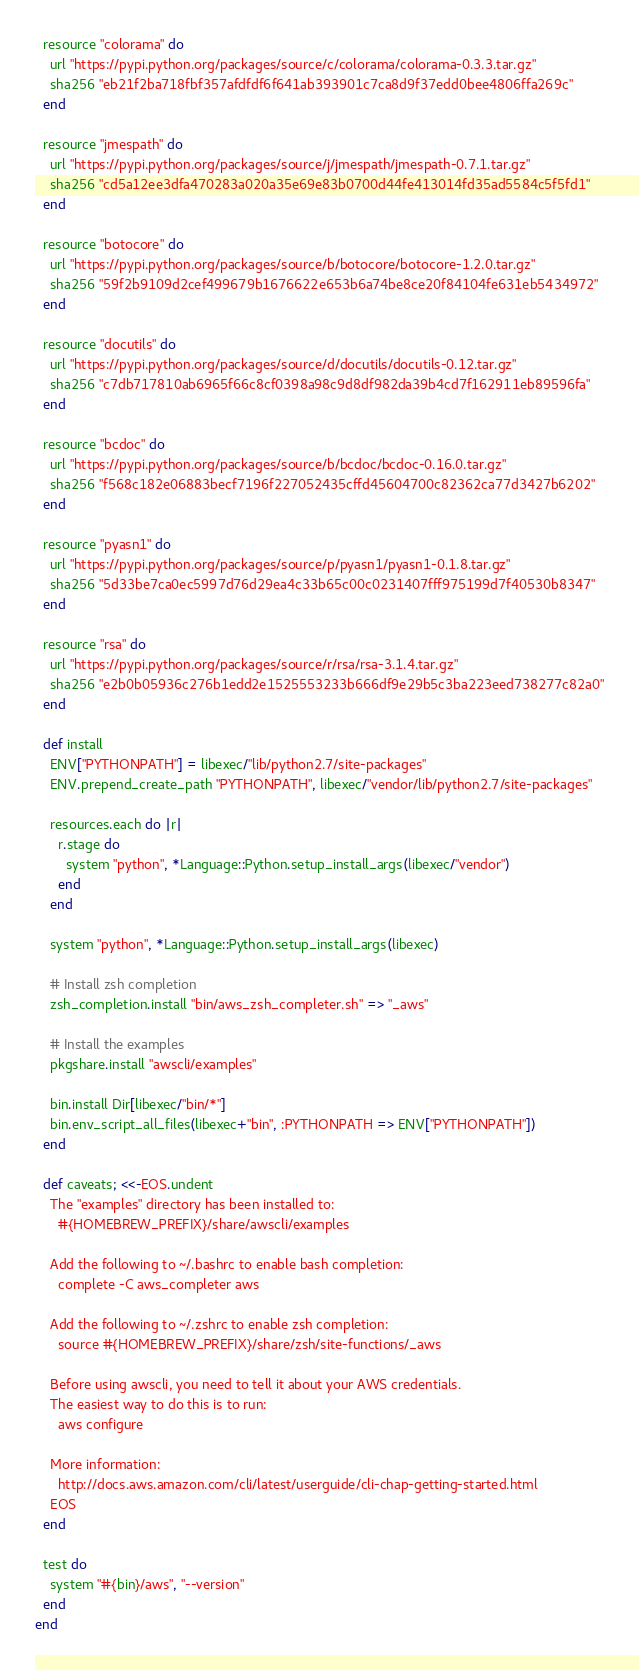Convert code to text. <code><loc_0><loc_0><loc_500><loc_500><_Ruby_>  resource "colorama" do
    url "https://pypi.python.org/packages/source/c/colorama/colorama-0.3.3.tar.gz"
    sha256 "eb21f2ba718fbf357afdfdf6f641ab393901c7ca8d9f37edd0bee4806ffa269c"
  end

  resource "jmespath" do
    url "https://pypi.python.org/packages/source/j/jmespath/jmespath-0.7.1.tar.gz"
    sha256 "cd5a12ee3dfa470283a020a35e69e83b0700d44fe413014fd35ad5584c5f5fd1"
  end

  resource "botocore" do
    url "https://pypi.python.org/packages/source/b/botocore/botocore-1.2.0.tar.gz"
    sha256 "59f2b9109d2cef499679b1676622e653b6a74be8ce20f84104fe631eb5434972"
  end

  resource "docutils" do
    url "https://pypi.python.org/packages/source/d/docutils/docutils-0.12.tar.gz"
    sha256 "c7db717810ab6965f66c8cf0398a98c9d8df982da39b4cd7f162911eb89596fa"
  end

  resource "bcdoc" do
    url "https://pypi.python.org/packages/source/b/bcdoc/bcdoc-0.16.0.tar.gz"
    sha256 "f568c182e06883becf7196f227052435cffd45604700c82362ca77d3427b6202"
  end

  resource "pyasn1" do
    url "https://pypi.python.org/packages/source/p/pyasn1/pyasn1-0.1.8.tar.gz"
    sha256 "5d33be7ca0ec5997d76d29ea4c33b65c00c0231407fff975199d7f40530b8347"
  end

  resource "rsa" do
    url "https://pypi.python.org/packages/source/r/rsa/rsa-3.1.4.tar.gz"
    sha256 "e2b0b05936c276b1edd2e1525553233b666df9e29b5c3ba223eed738277c82a0"
  end

  def install
    ENV["PYTHONPATH"] = libexec/"lib/python2.7/site-packages"
    ENV.prepend_create_path "PYTHONPATH", libexec/"vendor/lib/python2.7/site-packages"

    resources.each do |r|
      r.stage do
        system "python", *Language::Python.setup_install_args(libexec/"vendor")
      end
    end

    system "python", *Language::Python.setup_install_args(libexec)

    # Install zsh completion
    zsh_completion.install "bin/aws_zsh_completer.sh" => "_aws"

    # Install the examples
    pkgshare.install "awscli/examples"

    bin.install Dir[libexec/"bin/*"]
    bin.env_script_all_files(libexec+"bin", :PYTHONPATH => ENV["PYTHONPATH"])
  end

  def caveats; <<-EOS.undent
    The "examples" directory has been installed to:
      #{HOMEBREW_PREFIX}/share/awscli/examples

    Add the following to ~/.bashrc to enable bash completion:
      complete -C aws_completer aws

    Add the following to ~/.zshrc to enable zsh completion:
      source #{HOMEBREW_PREFIX}/share/zsh/site-functions/_aws

    Before using awscli, you need to tell it about your AWS credentials.
    The easiest way to do this is to run:
      aws configure

    More information:
      http://docs.aws.amazon.com/cli/latest/userguide/cli-chap-getting-started.html
    EOS
  end

  test do
    system "#{bin}/aws", "--version"
  end
end
</code> 